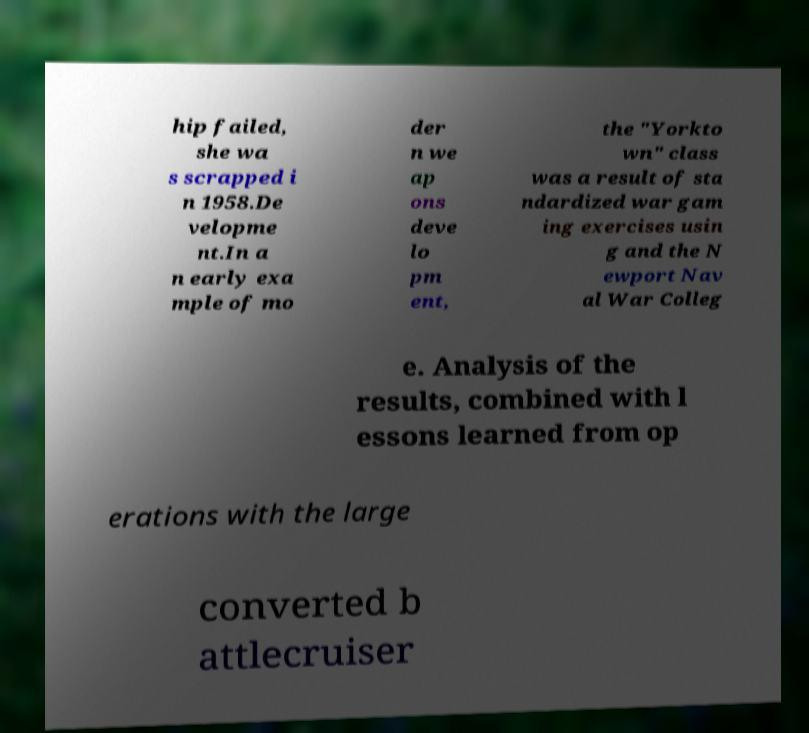What messages or text are displayed in this image? I need them in a readable, typed format. hip failed, she wa s scrapped i n 1958.De velopme nt.In a n early exa mple of mo der n we ap ons deve lo pm ent, the "Yorkto wn" class was a result of sta ndardized war gam ing exercises usin g and the N ewport Nav al War Colleg e. Analysis of the results, combined with l essons learned from op erations with the large converted b attlecruiser 